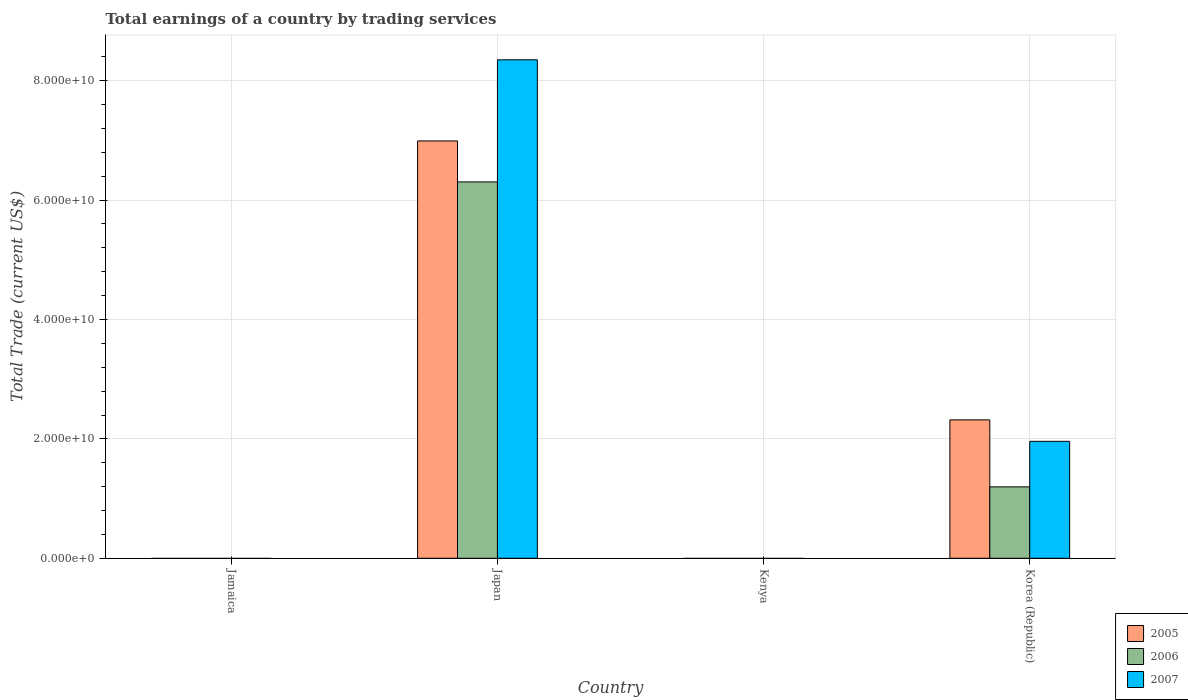Are the number of bars per tick equal to the number of legend labels?
Ensure brevity in your answer.  No. Are the number of bars on each tick of the X-axis equal?
Ensure brevity in your answer.  No. How many bars are there on the 2nd tick from the right?
Offer a terse response. 0. What is the label of the 3rd group of bars from the left?
Your answer should be compact. Kenya. In how many cases, is the number of bars for a given country not equal to the number of legend labels?
Your answer should be very brief. 2. What is the total earnings in 2006 in Jamaica?
Your response must be concise. 0. Across all countries, what is the maximum total earnings in 2007?
Your answer should be very brief. 8.35e+1. Across all countries, what is the minimum total earnings in 2007?
Your answer should be compact. 0. What is the total total earnings in 2006 in the graph?
Make the answer very short. 7.50e+1. What is the difference between the total earnings in 2005 in Japan and that in Korea (Republic)?
Offer a terse response. 4.67e+1. What is the difference between the total earnings in 2006 in Jamaica and the total earnings in 2005 in Japan?
Offer a terse response. -6.99e+1. What is the average total earnings in 2006 per country?
Keep it short and to the point. 1.88e+1. What is the difference between the total earnings of/in 2006 and total earnings of/in 2005 in Japan?
Ensure brevity in your answer.  -6.87e+09. What is the difference between the highest and the lowest total earnings in 2007?
Offer a very short reply. 8.35e+1. Is the sum of the total earnings in 2007 in Japan and Korea (Republic) greater than the maximum total earnings in 2006 across all countries?
Offer a very short reply. Yes. Is it the case that in every country, the sum of the total earnings in 2005 and total earnings in 2006 is greater than the total earnings in 2007?
Provide a short and direct response. No. How many countries are there in the graph?
Your answer should be compact. 4. What is the title of the graph?
Make the answer very short. Total earnings of a country by trading services. Does "2002" appear as one of the legend labels in the graph?
Give a very brief answer. No. What is the label or title of the Y-axis?
Ensure brevity in your answer.  Total Trade (current US$). What is the Total Trade (current US$) of 2006 in Jamaica?
Keep it short and to the point. 0. What is the Total Trade (current US$) in 2005 in Japan?
Make the answer very short. 6.99e+1. What is the Total Trade (current US$) of 2006 in Japan?
Give a very brief answer. 6.30e+1. What is the Total Trade (current US$) in 2007 in Japan?
Your response must be concise. 8.35e+1. What is the Total Trade (current US$) of 2005 in Kenya?
Provide a short and direct response. 0. What is the Total Trade (current US$) of 2005 in Korea (Republic)?
Offer a very short reply. 2.32e+1. What is the Total Trade (current US$) in 2006 in Korea (Republic)?
Your answer should be very brief. 1.20e+1. What is the Total Trade (current US$) in 2007 in Korea (Republic)?
Provide a succinct answer. 1.96e+1. Across all countries, what is the maximum Total Trade (current US$) in 2005?
Make the answer very short. 6.99e+1. Across all countries, what is the maximum Total Trade (current US$) in 2006?
Give a very brief answer. 6.30e+1. Across all countries, what is the maximum Total Trade (current US$) in 2007?
Keep it short and to the point. 8.35e+1. Across all countries, what is the minimum Total Trade (current US$) in 2006?
Give a very brief answer. 0. What is the total Total Trade (current US$) in 2005 in the graph?
Offer a very short reply. 9.31e+1. What is the total Total Trade (current US$) of 2006 in the graph?
Make the answer very short. 7.50e+1. What is the total Total Trade (current US$) in 2007 in the graph?
Keep it short and to the point. 1.03e+11. What is the difference between the Total Trade (current US$) in 2005 in Japan and that in Korea (Republic)?
Provide a short and direct response. 4.67e+1. What is the difference between the Total Trade (current US$) of 2006 in Japan and that in Korea (Republic)?
Offer a very short reply. 5.11e+1. What is the difference between the Total Trade (current US$) of 2007 in Japan and that in Korea (Republic)?
Keep it short and to the point. 6.39e+1. What is the difference between the Total Trade (current US$) of 2005 in Japan and the Total Trade (current US$) of 2006 in Korea (Republic)?
Offer a very short reply. 5.80e+1. What is the difference between the Total Trade (current US$) in 2005 in Japan and the Total Trade (current US$) in 2007 in Korea (Republic)?
Make the answer very short. 5.03e+1. What is the difference between the Total Trade (current US$) in 2006 in Japan and the Total Trade (current US$) in 2007 in Korea (Republic)?
Your answer should be very brief. 4.35e+1. What is the average Total Trade (current US$) of 2005 per country?
Ensure brevity in your answer.  2.33e+1. What is the average Total Trade (current US$) of 2006 per country?
Provide a short and direct response. 1.88e+1. What is the average Total Trade (current US$) in 2007 per country?
Keep it short and to the point. 2.58e+1. What is the difference between the Total Trade (current US$) in 2005 and Total Trade (current US$) in 2006 in Japan?
Provide a short and direct response. 6.87e+09. What is the difference between the Total Trade (current US$) in 2005 and Total Trade (current US$) in 2007 in Japan?
Your answer should be compact. -1.36e+1. What is the difference between the Total Trade (current US$) of 2006 and Total Trade (current US$) of 2007 in Japan?
Ensure brevity in your answer.  -2.05e+1. What is the difference between the Total Trade (current US$) in 2005 and Total Trade (current US$) in 2006 in Korea (Republic)?
Provide a short and direct response. 1.12e+1. What is the difference between the Total Trade (current US$) of 2005 and Total Trade (current US$) of 2007 in Korea (Republic)?
Ensure brevity in your answer.  3.59e+09. What is the difference between the Total Trade (current US$) of 2006 and Total Trade (current US$) of 2007 in Korea (Republic)?
Ensure brevity in your answer.  -7.63e+09. What is the ratio of the Total Trade (current US$) of 2005 in Japan to that in Korea (Republic)?
Offer a terse response. 3.02. What is the ratio of the Total Trade (current US$) of 2006 in Japan to that in Korea (Republic)?
Provide a short and direct response. 5.27. What is the ratio of the Total Trade (current US$) of 2007 in Japan to that in Korea (Republic)?
Your answer should be very brief. 4.26. What is the difference between the highest and the lowest Total Trade (current US$) of 2005?
Provide a succinct answer. 6.99e+1. What is the difference between the highest and the lowest Total Trade (current US$) in 2006?
Provide a short and direct response. 6.30e+1. What is the difference between the highest and the lowest Total Trade (current US$) in 2007?
Make the answer very short. 8.35e+1. 